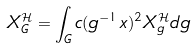<formula> <loc_0><loc_0><loc_500><loc_500>X _ { G } ^ { \mathcal { H } } = \int _ { G } c ( g ^ { - 1 } x ) ^ { 2 } X _ { g } ^ { \mathcal { H } } d g</formula> 